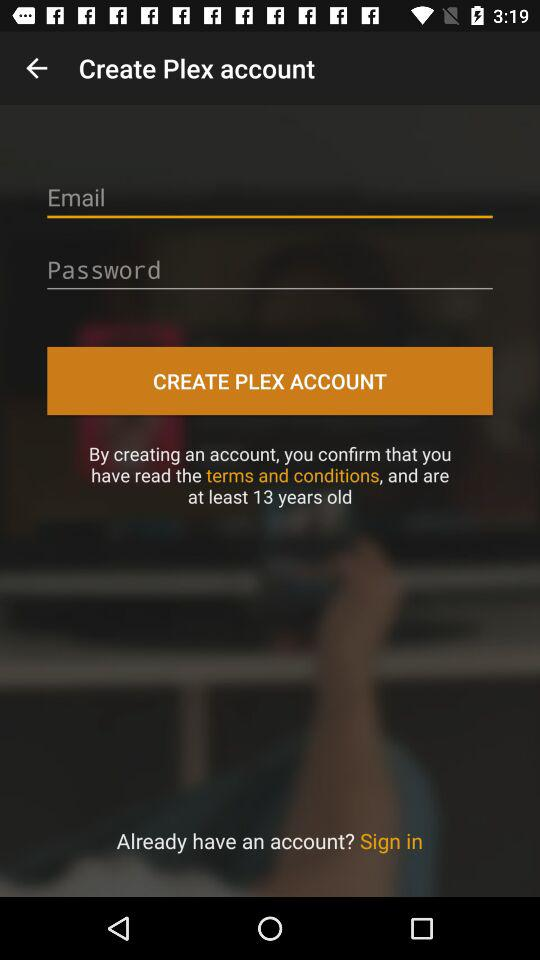What are the requirements to create a Plex account? The requirements to create a Plex account are an email and password. 